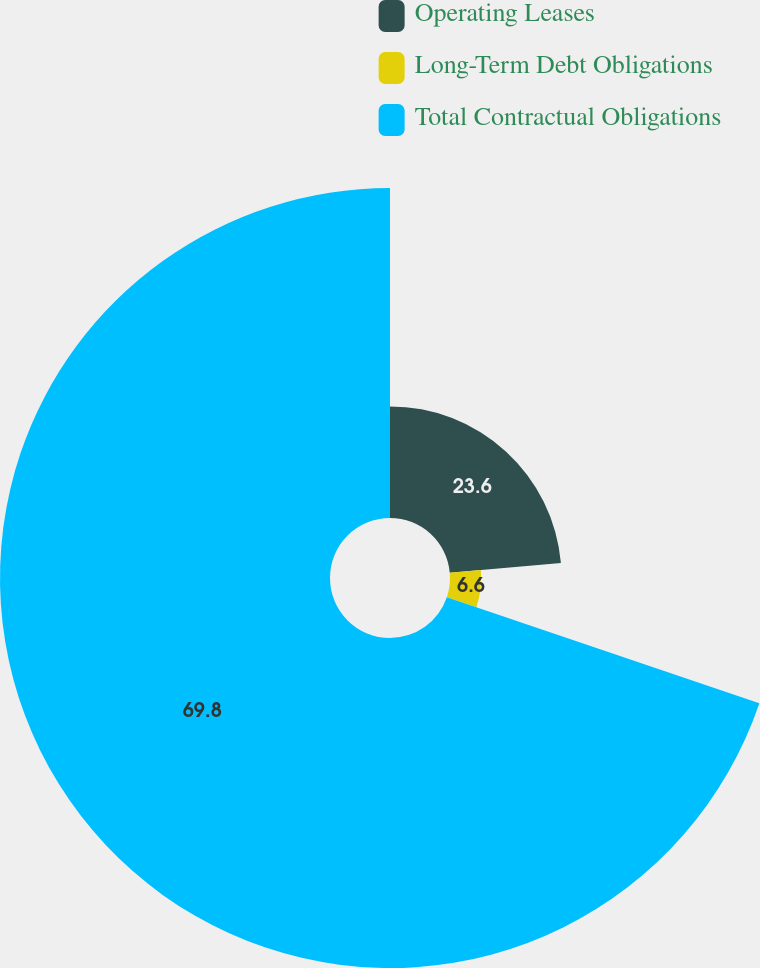Convert chart. <chart><loc_0><loc_0><loc_500><loc_500><pie_chart><fcel>Operating Leases<fcel>Long-Term Debt Obligations<fcel>Total Contractual Obligations<nl><fcel>23.6%<fcel>6.6%<fcel>69.8%<nl></chart> 